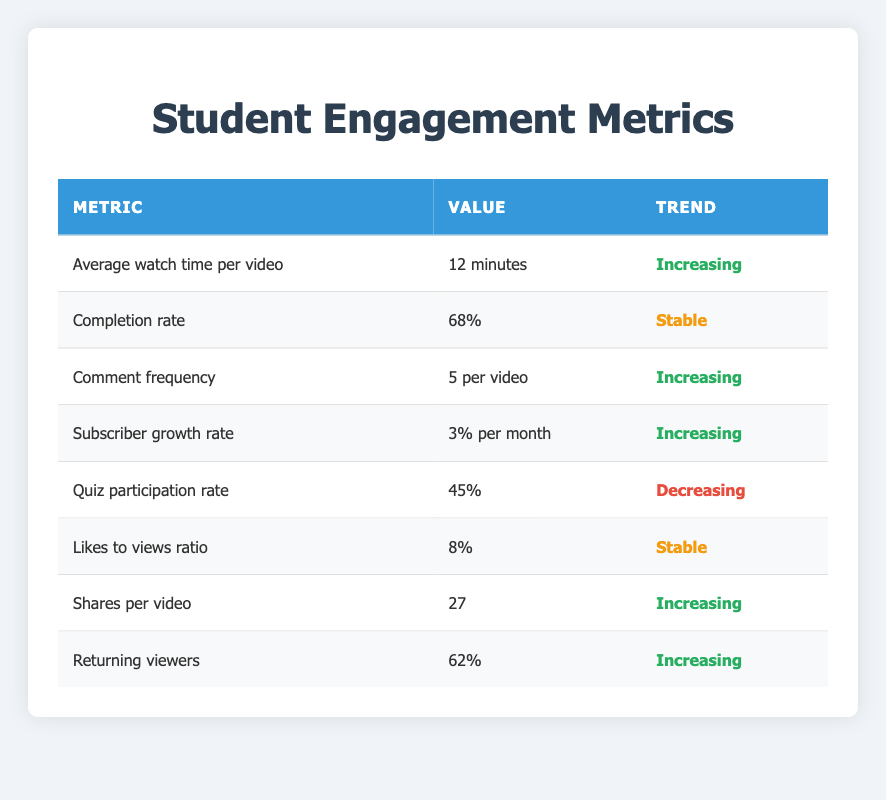What is the average watch time per video? The table states that the average watch time per video is listed as "12 minutes." Therefore, this metric can be retrieved directly from the row associated with it.
Answer: 12 minutes What is the current completion rate for the online courses? The table shows the completion rate as "68%." This value is found in the row dedicated to the completion rate.
Answer: 68% Is the likes to views ratio stable? Yes, the table indicates that the likes to views ratio is "8%" and describes its trend as "Stable." This confirms that the likes to views ratio has not changed.
Answer: Yes Which metric has a decreasing trend? The only metric that shows a decreasing trend is the quiz participation rate, which is at "45%." This can be confirmed by checking the trend column for all metrics listed.
Answer: Quiz participation rate How many more shares per video are there compared to the quiz participation rate? The table states there are "27 shares per video" and "45% quiz participation rate." Since shares are a straightforward count, we consider the shares value (27) as higher than the percentage-based quiz participation (45%). As we are not converting percentages to counts, we consider this as just a different format of measurement.
Answer: 27 shares (more shares than percentage of quiz participation) What percentage of returning viewers is there? According to the table, the percentage of returning viewers is "62%." This value is retrieved directly from the returning viewers row.
Answer: 62% Is the comment frequency increasing or stable? The table indicates that the comment frequency is "5 per video" and its trend is "Increasing." Therefore, we can affirmatively conclude that the comment frequency is indeed increasing.
Answer: Increasing How does the completion rate compare to the average watch time per video? The completion rate is "68%," while the average watch time per video is "12 minutes." To compare, we note that one is a percentage and the other is a duration measure; thus, we cannot perform direct mathematical operations on them. However, they both indicate positive engagement metrics.
Answer: Not directly comparable What overall trend do you observe for engagement metrics in the table? The trends show that most engagement metrics, such as average watch time, comment frequency, shares per video, and returning viewers are increasing. The completion rate is stable, and the quiz participation rate is decreasing, demonstrating a varied engagement level with room for improvement in quiz participation.
Answer: Mixed trends 